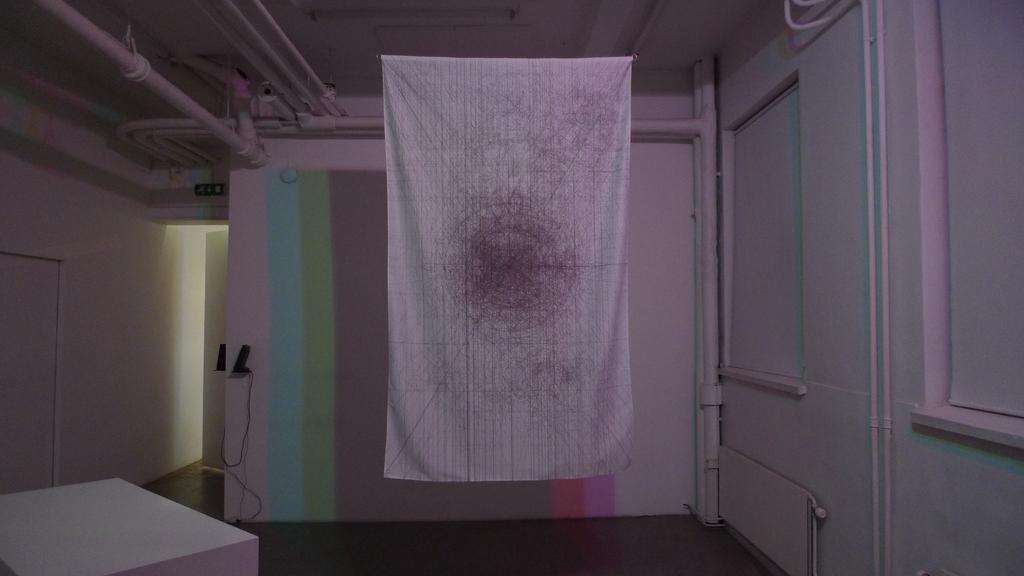What type of location is depicted in the image? The image is an inside view of a room. What can be seen hanging in the room? There is a towel in the room. What infrastructure elements are visible in the room? There are pipes and cables visible in the room. What can be found in the room besides the towel and infrastructure elements? There are objects in the room. What separates the room from other spaces? There is a wall in the room. What is the profit margin of the downtown area in the image? There is no downtown area or mention of profit in the image; it is an inside view of a room with various objects and elements. 